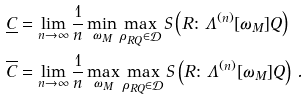<formula> <loc_0><loc_0><loc_500><loc_500>\underline { C } & = \lim _ { n \rightarrow \infty } \frac { 1 } { n } \min _ { \omega _ { M } } \max _ { \rho _ { R Q } \in \mathcal { D } } S \left ( R \colon \Lambda ^ { ( n ) } [ \omega _ { M } ] Q \right ) \\ \overline { C } & = \lim _ { n \rightarrow \infty } \frac { 1 } { n } \max _ { \omega _ { M } } \max _ { \rho _ { R Q } \in \mathcal { D } } S \left ( R \colon \Lambda ^ { ( n ) } [ \omega _ { M } ] Q \right ) \, .</formula> 